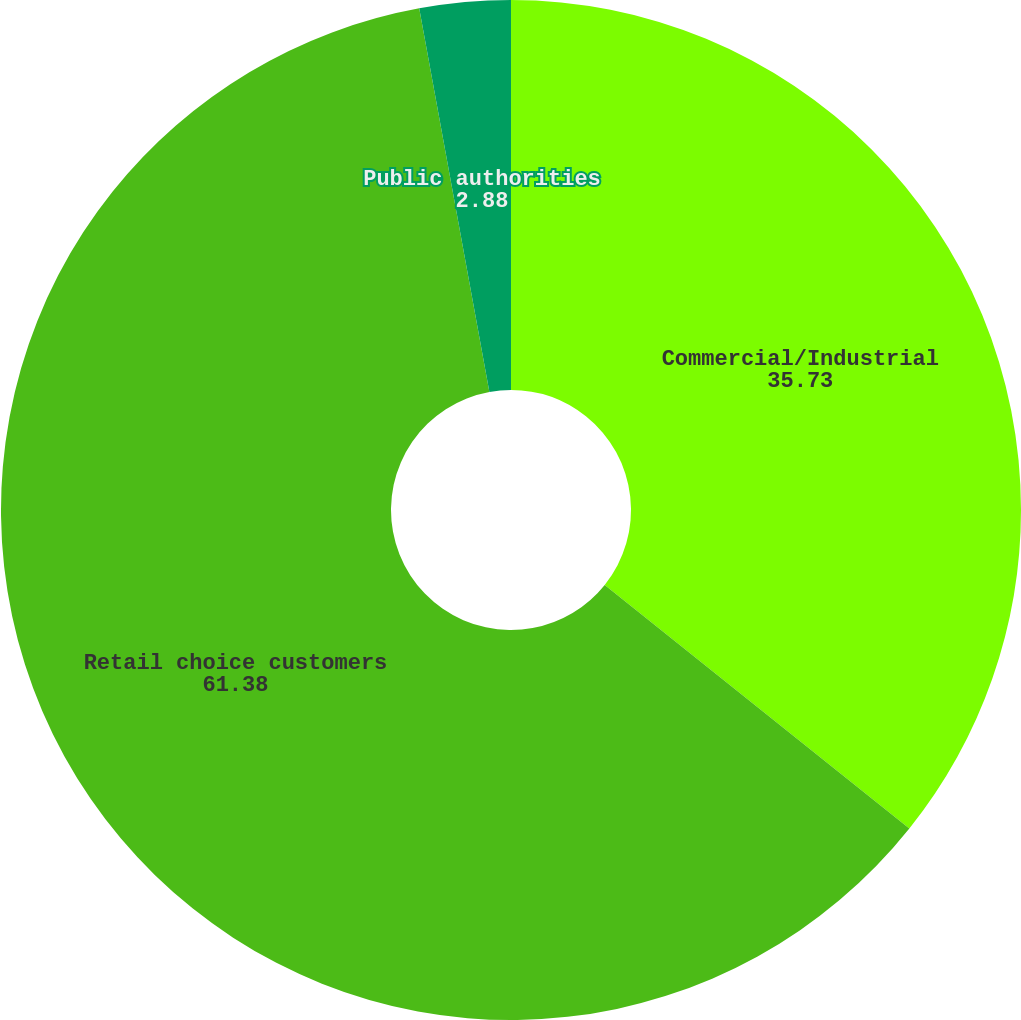Convert chart. <chart><loc_0><loc_0><loc_500><loc_500><pie_chart><fcel>Commercial/Industrial<fcel>Retail choice customers<fcel>Public authorities<nl><fcel>35.73%<fcel>61.38%<fcel>2.88%<nl></chart> 